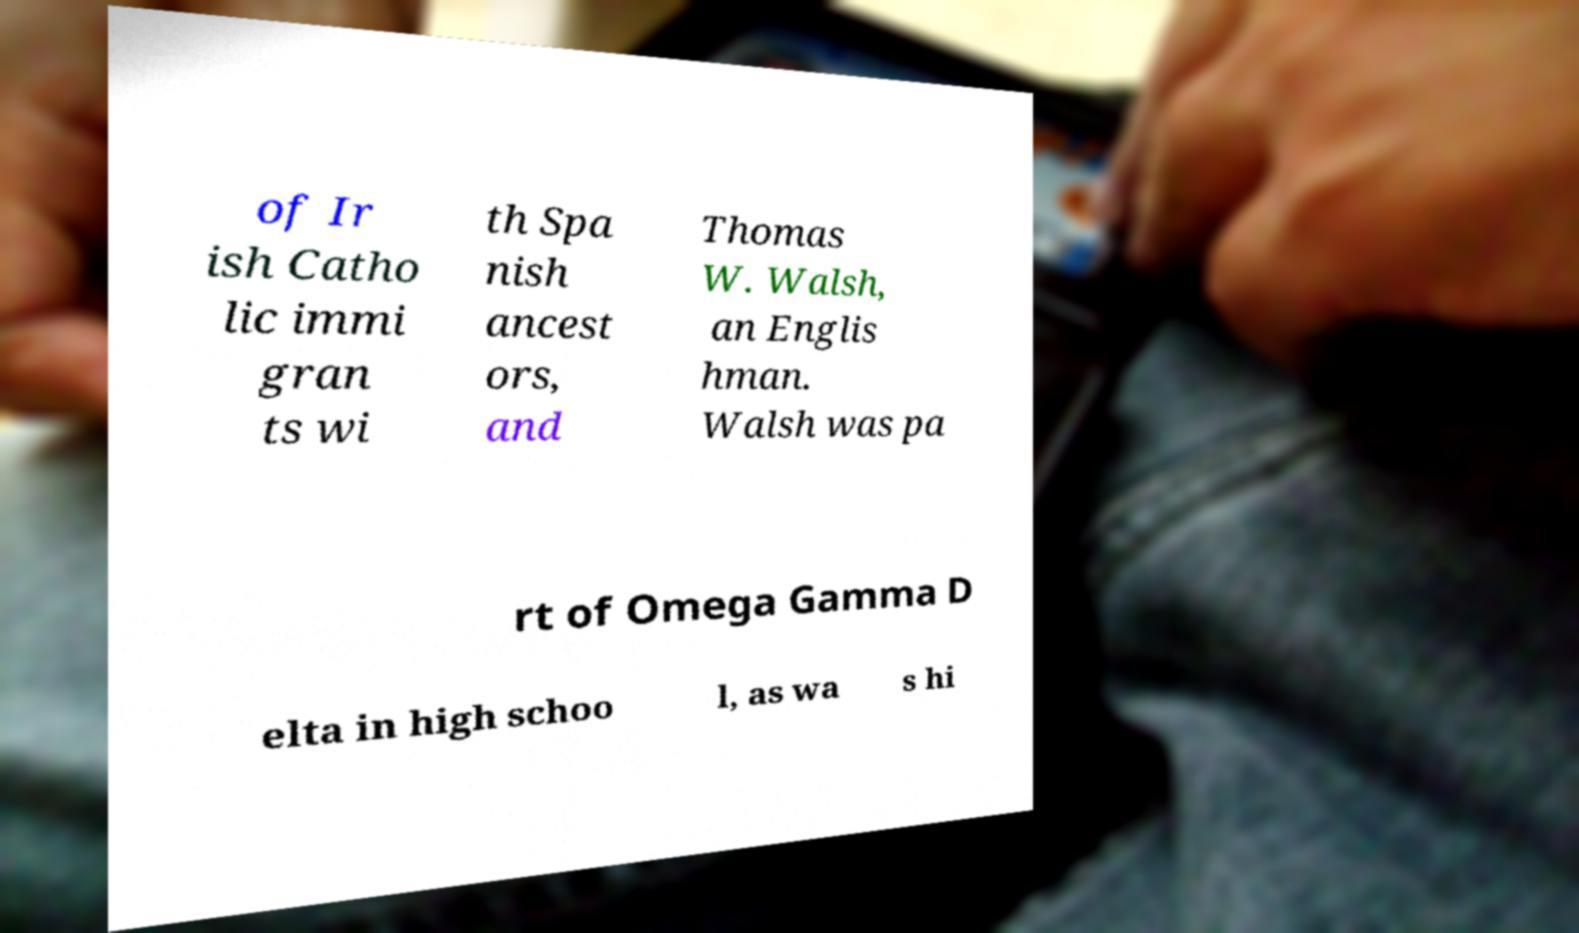Could you assist in decoding the text presented in this image and type it out clearly? of Ir ish Catho lic immi gran ts wi th Spa nish ancest ors, and Thomas W. Walsh, an Englis hman. Walsh was pa rt of Omega Gamma D elta in high schoo l, as wa s hi 